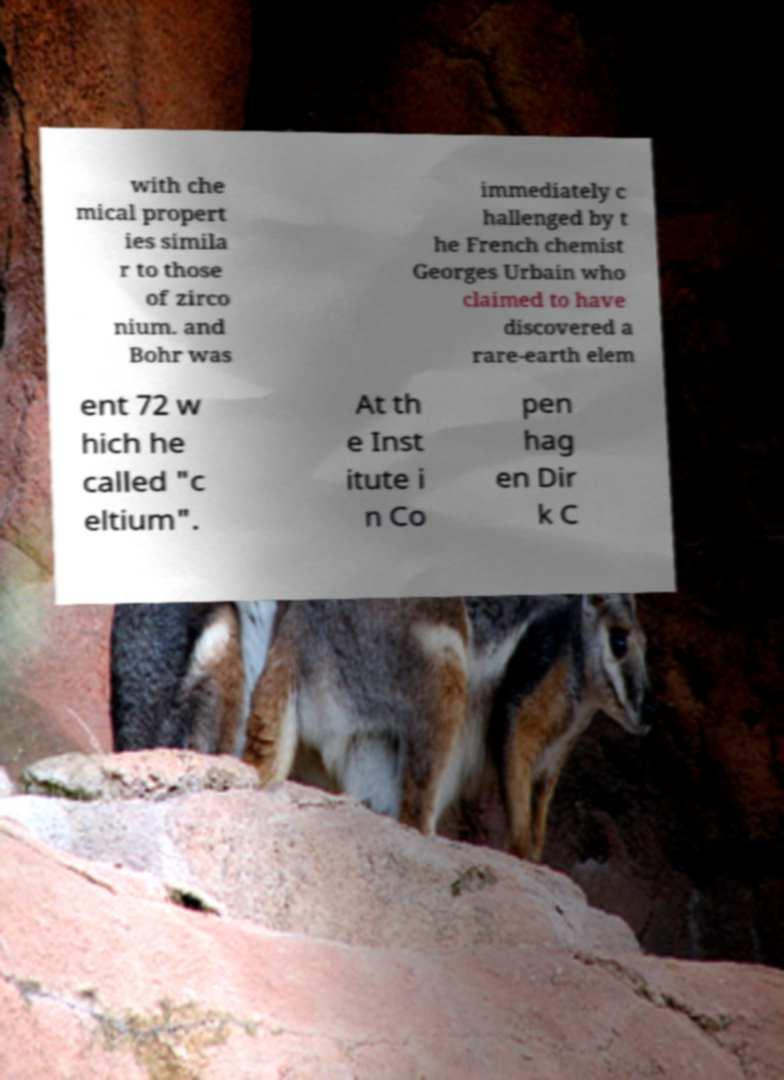Could you assist in decoding the text presented in this image and type it out clearly? with che mical propert ies simila r to those of zirco nium. and Bohr was immediately c hallenged by t he French chemist Georges Urbain who claimed to have discovered a rare-earth elem ent 72 w hich he called "c eltium". At th e Inst itute i n Co pen hag en Dir k C 